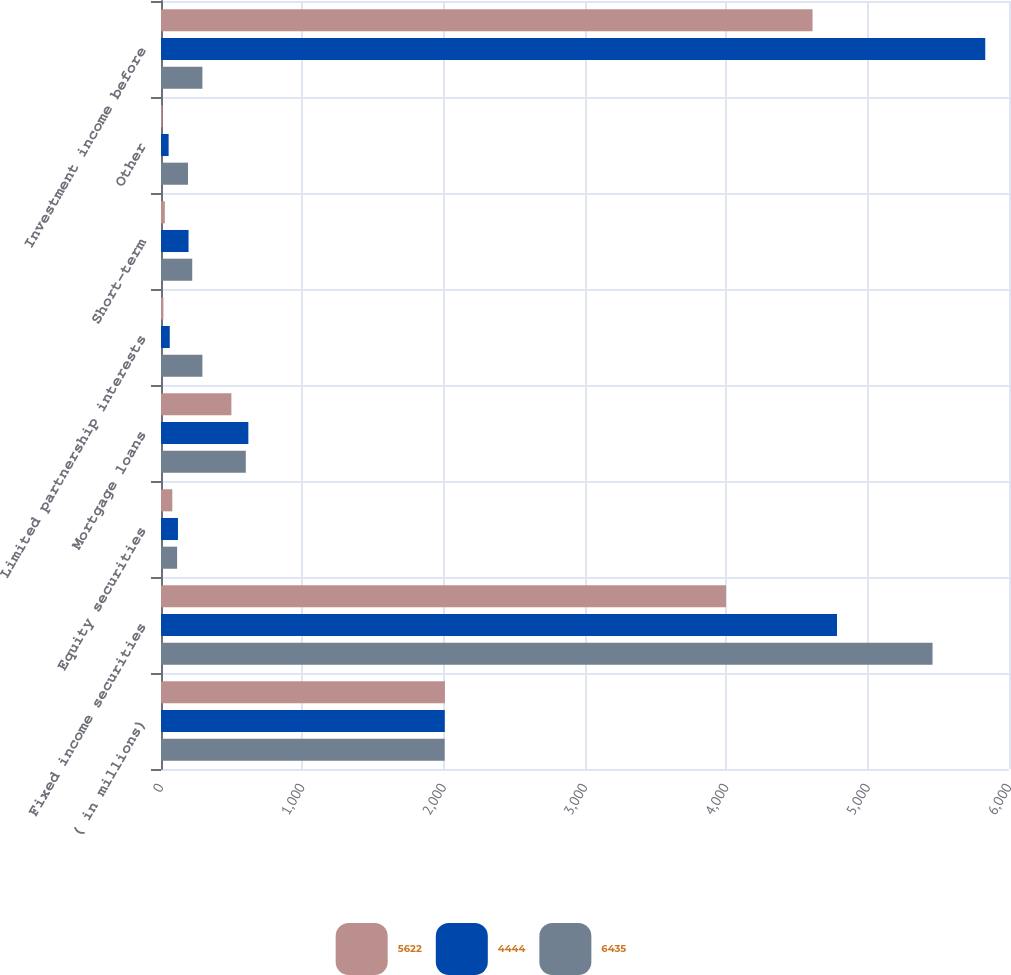Convert chart. <chart><loc_0><loc_0><loc_500><loc_500><stacked_bar_chart><ecel><fcel>( in millions)<fcel>Fixed income securities<fcel>Equity securities<fcel>Mortgage loans<fcel>Limited partnership interests<fcel>Short-term<fcel>Other<fcel>Investment income before<nl><fcel>5622<fcel>2009<fcel>3998<fcel>80<fcel>498<fcel>17<fcel>27<fcel>10<fcel>4610<nl><fcel>4444<fcel>2008<fcel>4783<fcel>120<fcel>618<fcel>62<fcel>195<fcel>54<fcel>5832<nl><fcel>6435<fcel>2007<fcel>5459<fcel>114<fcel>600<fcel>293<fcel>221<fcel>191<fcel>293<nl></chart> 